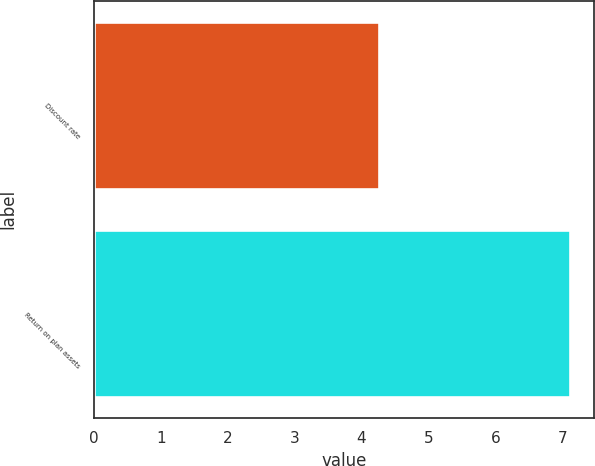Convert chart. <chart><loc_0><loc_0><loc_500><loc_500><bar_chart><fcel>Discount rate<fcel>Return on plan assets<nl><fcel>4.26<fcel>7.12<nl></chart> 